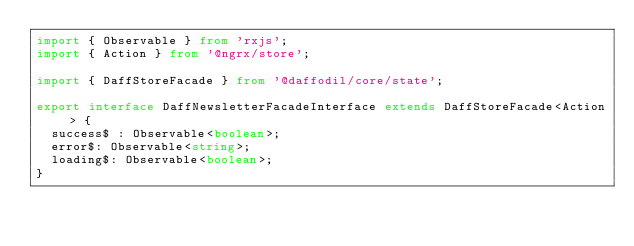<code> <loc_0><loc_0><loc_500><loc_500><_TypeScript_>import { Observable } from 'rxjs';
import { Action } from '@ngrx/store';

import { DaffStoreFacade } from '@daffodil/core/state';

export interface DaffNewsletterFacadeInterface extends DaffStoreFacade<Action> {
  success$ : Observable<boolean>;
  error$: Observable<string>;
  loading$: Observable<boolean>;
}
</code> 